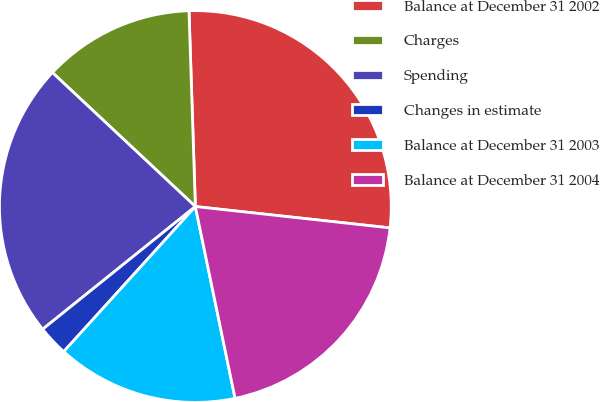Convert chart. <chart><loc_0><loc_0><loc_500><loc_500><pie_chart><fcel>Balance at December 31 2002<fcel>Charges<fcel>Spending<fcel>Changes in estimate<fcel>Balance at December 31 2003<fcel>Balance at December 31 2004<nl><fcel>27.26%<fcel>12.5%<fcel>22.76%<fcel>2.5%<fcel>14.98%<fcel>20.01%<nl></chart> 